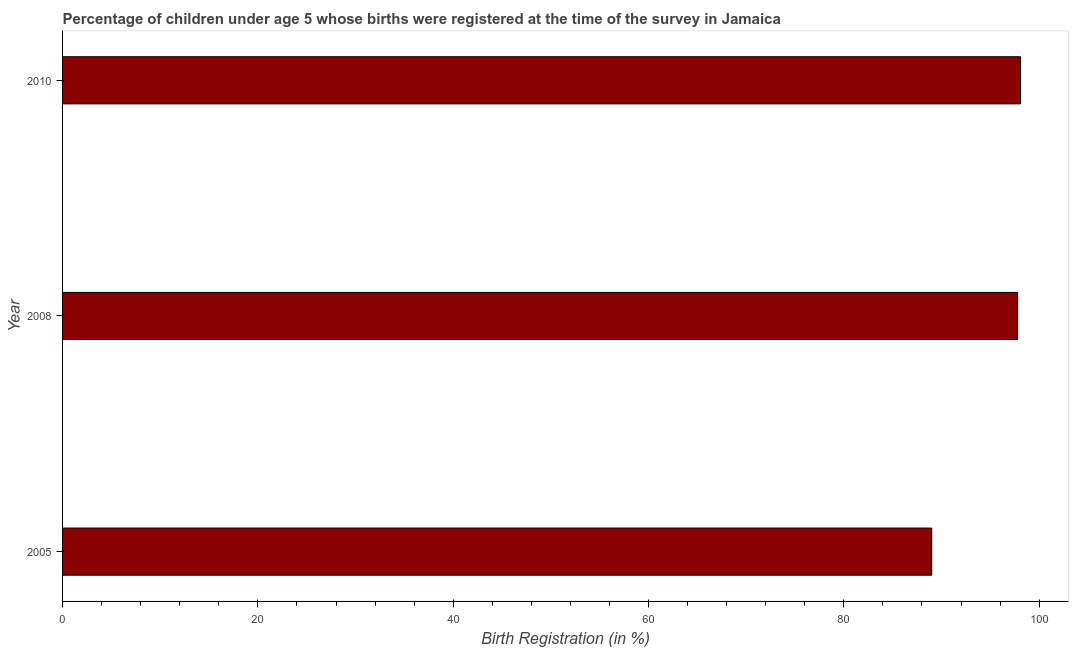Does the graph contain any zero values?
Offer a terse response. No. What is the title of the graph?
Offer a terse response. Percentage of children under age 5 whose births were registered at the time of the survey in Jamaica. What is the label or title of the X-axis?
Offer a terse response. Birth Registration (in %). What is the birth registration in 2008?
Your response must be concise. 97.8. Across all years, what is the maximum birth registration?
Your answer should be compact. 98.1. Across all years, what is the minimum birth registration?
Your response must be concise. 89. In which year was the birth registration minimum?
Keep it short and to the point. 2005. What is the sum of the birth registration?
Your answer should be very brief. 284.9. What is the average birth registration per year?
Provide a succinct answer. 94.97. What is the median birth registration?
Offer a terse response. 97.8. What is the ratio of the birth registration in 2005 to that in 2008?
Ensure brevity in your answer.  0.91. Is the birth registration in 2008 less than that in 2010?
Your answer should be very brief. Yes. What is the difference between the highest and the second highest birth registration?
Offer a terse response. 0.3. Is the sum of the birth registration in 2005 and 2008 greater than the maximum birth registration across all years?
Make the answer very short. Yes. In how many years, is the birth registration greater than the average birth registration taken over all years?
Offer a very short reply. 2. How many years are there in the graph?
Provide a succinct answer. 3. Are the values on the major ticks of X-axis written in scientific E-notation?
Offer a terse response. No. What is the Birth Registration (in %) of 2005?
Your response must be concise. 89. What is the Birth Registration (in %) of 2008?
Offer a very short reply. 97.8. What is the Birth Registration (in %) of 2010?
Your response must be concise. 98.1. What is the difference between the Birth Registration (in %) in 2005 and 2008?
Your response must be concise. -8.8. What is the difference between the Birth Registration (in %) in 2008 and 2010?
Make the answer very short. -0.3. What is the ratio of the Birth Registration (in %) in 2005 to that in 2008?
Provide a short and direct response. 0.91. What is the ratio of the Birth Registration (in %) in 2005 to that in 2010?
Offer a very short reply. 0.91. What is the ratio of the Birth Registration (in %) in 2008 to that in 2010?
Give a very brief answer. 1. 